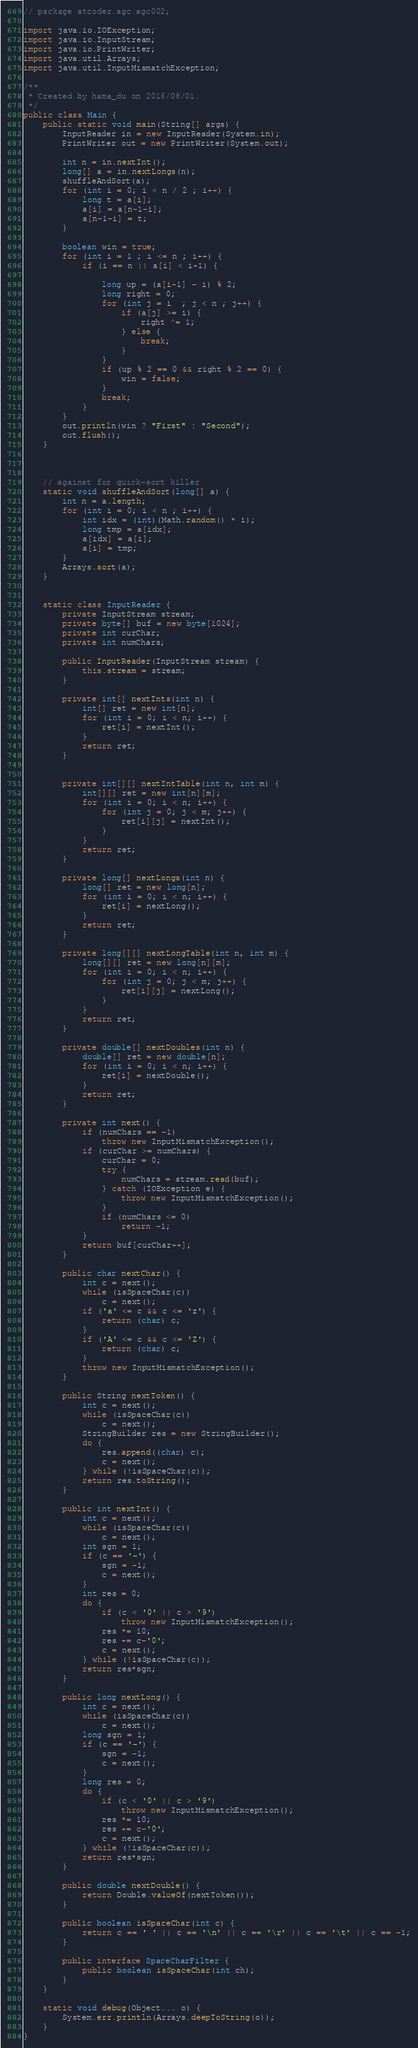<code> <loc_0><loc_0><loc_500><loc_500><_Java_>// package atcoder.agc.agc002;

import java.io.IOException;
import java.io.InputStream;
import java.io.PrintWriter;
import java.util.Arrays;
import java.util.InputMismatchException;

/**
 * Created by hama_du on 2016/08/01.
 */
public class Main {
    public static void main(String[] args) {
        InputReader in = new InputReader(System.in);
        PrintWriter out = new PrintWriter(System.out);

        int n = in.nextInt();
        long[] a = in.nextLongs(n);
        shuffleAndSort(a);
        for (int i = 0; i < n / 2 ; i++) {
            long t = a[i];
            a[i] = a[n-1-i];
            a[n-1-i] = t;
        }

        boolean win = true;
        for (int i = 1 ; i <= n ; i++) {
            if (i == n || a[i] < i+1) {

                long up = (a[i-1] - i) % 2;
                long right = 0;
                for (int j = i  ; j < n ; j++) {
                    if (a[j] >= i) {
                        right ^= 1;
                    } else {
                        break;
                    }
                }
                if (up % 2 == 0 && right % 2 == 0) {
                    win = false;
                }
                break;
            }
        }
        out.println(win ? "First" : "Second");
        out.flush();
    }



    // against for quick-sort killer
    static void shuffleAndSort(long[] a) {
        int n = a.length;
        for (int i = 0; i < n ; i++) {
            int idx = (int)(Math.random() * i);
            long tmp = a[idx];
            a[idx] = a[i];
            a[i] = tmp;
        }
        Arrays.sort(a);
    }


    static class InputReader {
        private InputStream stream;
        private byte[] buf = new byte[1024];
        private int curChar;
        private int numChars;

        public InputReader(InputStream stream) {
            this.stream = stream;
        }

        private int[] nextInts(int n) {
            int[] ret = new int[n];
            for (int i = 0; i < n; i++) {
                ret[i] = nextInt();
            }
            return ret;
        }


        private int[][] nextIntTable(int n, int m) {
            int[][] ret = new int[n][m];
            for (int i = 0; i < n; i++) {
                for (int j = 0; j < m; j++) {
                    ret[i][j] = nextInt();
                }
            }
            return ret;
        }

        private long[] nextLongs(int n) {
            long[] ret = new long[n];
            for (int i = 0; i < n; i++) {
                ret[i] = nextLong();
            }
            return ret;
        }

        private long[][] nextLongTable(int n, int m) {
            long[][] ret = new long[n][m];
            for (int i = 0; i < n; i++) {
                for (int j = 0; j < m; j++) {
                    ret[i][j] = nextLong();
                }
            }
            return ret;
        }

        private double[] nextDoubles(int n) {
            double[] ret = new double[n];
            for (int i = 0; i < n; i++) {
                ret[i] = nextDouble();
            }
            return ret;
        }

        private int next() {
            if (numChars == -1)
                throw new InputMismatchException();
            if (curChar >= numChars) {
                curChar = 0;
                try {
                    numChars = stream.read(buf);
                } catch (IOException e) {
                    throw new InputMismatchException();
                }
                if (numChars <= 0)
                    return -1;
            }
            return buf[curChar++];
        }

        public char nextChar() {
            int c = next();
            while (isSpaceChar(c))
                c = next();
            if ('a' <= c && c <= 'z') {
                return (char) c;
            }
            if ('A' <= c && c <= 'Z') {
                return (char) c;
            }
            throw new InputMismatchException();
        }

        public String nextToken() {
            int c = next();
            while (isSpaceChar(c))
                c = next();
            StringBuilder res = new StringBuilder();
            do {
                res.append((char) c);
                c = next();
            } while (!isSpaceChar(c));
            return res.toString();
        }

        public int nextInt() {
            int c = next();
            while (isSpaceChar(c))
                c = next();
            int sgn = 1;
            if (c == '-') {
                sgn = -1;
                c = next();
            }
            int res = 0;
            do {
                if (c < '0' || c > '9')
                    throw new InputMismatchException();
                res *= 10;
                res += c-'0';
                c = next();
            } while (!isSpaceChar(c));
            return res*sgn;
        }

        public long nextLong() {
            int c = next();
            while (isSpaceChar(c))
                c = next();
            long sgn = 1;
            if (c == '-') {
                sgn = -1;
                c = next();
            }
            long res = 0;
            do {
                if (c < '0' || c > '9')
                    throw new InputMismatchException();
                res *= 10;
                res += c-'0';
                c = next();
            } while (!isSpaceChar(c));
            return res*sgn;
        }

        public double nextDouble() {
            return Double.valueOf(nextToken());
        }

        public boolean isSpaceChar(int c) {
            return c == ' ' || c == '\n' || c == '\r' || c == '\t' || c == -1;
        }

        public interface SpaceCharFilter {
            public boolean isSpaceChar(int ch);
        }
    }

    static void debug(Object... o) {
        System.err.println(Arrays.deepToString(o));
    }
}
</code> 